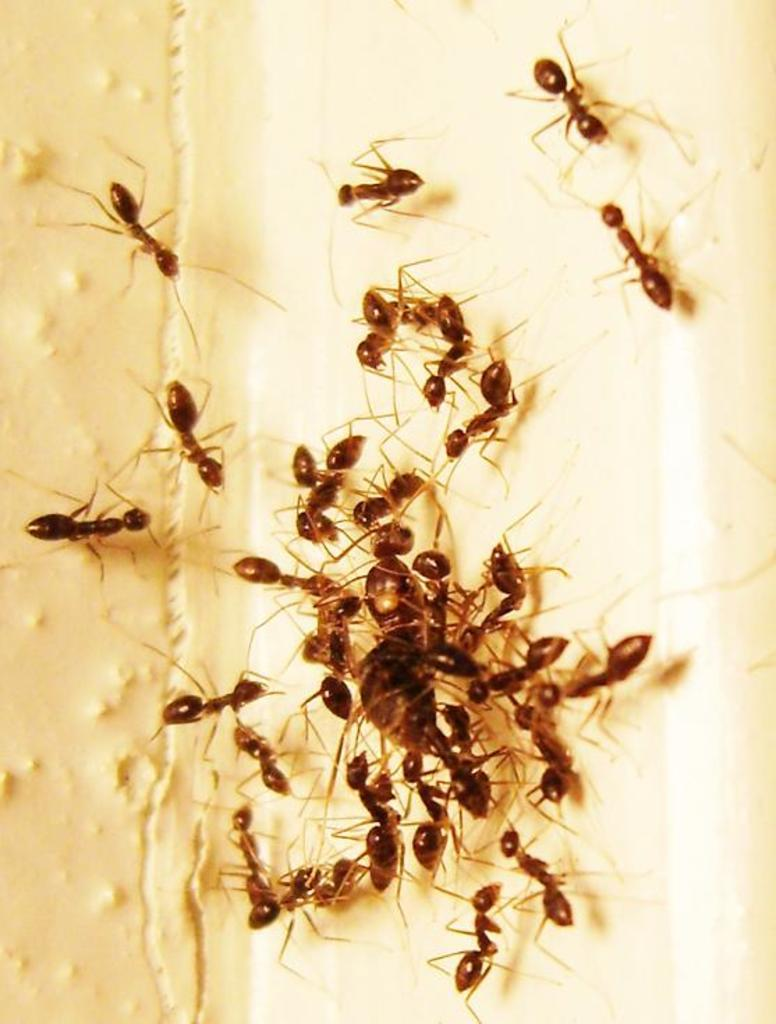What type of creatures can be seen on the surface in the image? There are ants on the surface in the image. How many bags can be seen in the image? There are no bags present in the image. What type of answer can be found in the image? There is no answer present in the image; it is a visual representation of ants on a surface. How many boys are visible in the image? There are no boys visible in the image; it features ants on a surface. 